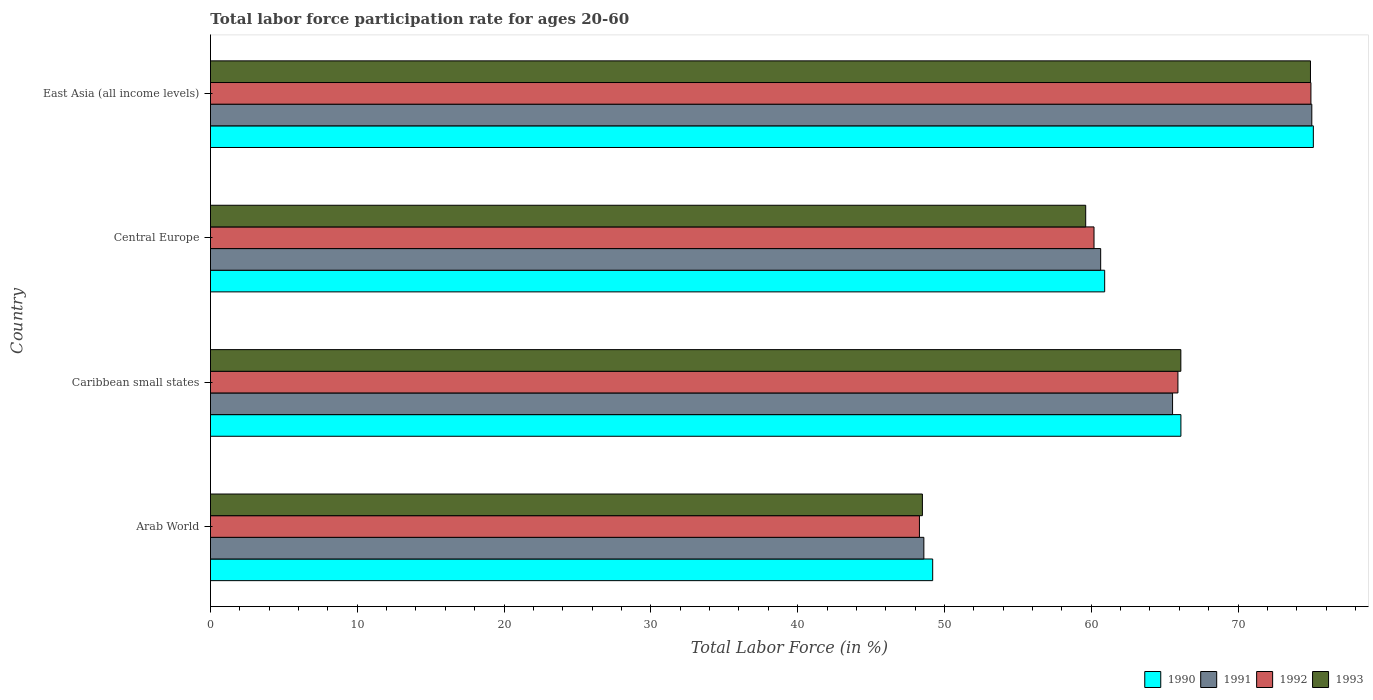How many groups of bars are there?
Give a very brief answer. 4. Are the number of bars per tick equal to the number of legend labels?
Make the answer very short. Yes. Are the number of bars on each tick of the Y-axis equal?
Offer a terse response. Yes. How many bars are there on the 3rd tick from the bottom?
Offer a very short reply. 4. What is the label of the 3rd group of bars from the top?
Your answer should be very brief. Caribbean small states. What is the labor force participation rate in 1991 in East Asia (all income levels)?
Provide a succinct answer. 75.03. Across all countries, what is the maximum labor force participation rate in 1993?
Keep it short and to the point. 74.93. Across all countries, what is the minimum labor force participation rate in 1992?
Offer a terse response. 48.3. In which country was the labor force participation rate in 1992 maximum?
Offer a terse response. East Asia (all income levels). In which country was the labor force participation rate in 1992 minimum?
Your answer should be very brief. Arab World. What is the total labor force participation rate in 1990 in the graph?
Make the answer very short. 251.35. What is the difference between the labor force participation rate in 1991 in Caribbean small states and that in Central Europe?
Give a very brief answer. 4.9. What is the difference between the labor force participation rate in 1991 in Central Europe and the labor force participation rate in 1992 in East Asia (all income levels)?
Ensure brevity in your answer.  -14.32. What is the average labor force participation rate in 1992 per country?
Keep it short and to the point. 62.34. What is the difference between the labor force participation rate in 1990 and labor force participation rate in 1993 in Arab World?
Offer a terse response. 0.7. In how many countries, is the labor force participation rate in 1991 greater than 28 %?
Provide a short and direct response. 4. What is the ratio of the labor force participation rate in 1993 in Caribbean small states to that in Central Europe?
Offer a terse response. 1.11. Is the labor force participation rate in 1992 in Arab World less than that in Caribbean small states?
Provide a succinct answer. Yes. What is the difference between the highest and the second highest labor force participation rate in 1993?
Provide a succinct answer. 8.83. What is the difference between the highest and the lowest labor force participation rate in 1993?
Keep it short and to the point. 26.44. In how many countries, is the labor force participation rate in 1993 greater than the average labor force participation rate in 1993 taken over all countries?
Your answer should be compact. 2. Is the sum of the labor force participation rate in 1990 in Central Europe and East Asia (all income levels) greater than the maximum labor force participation rate in 1993 across all countries?
Offer a very short reply. Yes. Is it the case that in every country, the sum of the labor force participation rate in 1992 and labor force participation rate in 1993 is greater than the sum of labor force participation rate in 1990 and labor force participation rate in 1991?
Your answer should be compact. No. What does the 3rd bar from the bottom in Central Europe represents?
Your answer should be very brief. 1992. Is it the case that in every country, the sum of the labor force participation rate in 1991 and labor force participation rate in 1993 is greater than the labor force participation rate in 1990?
Your answer should be very brief. Yes. How many bars are there?
Provide a short and direct response. 16. Are the values on the major ticks of X-axis written in scientific E-notation?
Offer a very short reply. No. Does the graph contain any zero values?
Give a very brief answer. No. Where does the legend appear in the graph?
Your answer should be very brief. Bottom right. How are the legend labels stacked?
Give a very brief answer. Horizontal. What is the title of the graph?
Make the answer very short. Total labor force participation rate for ages 20-60. What is the label or title of the Y-axis?
Ensure brevity in your answer.  Country. What is the Total Labor Force (in %) of 1990 in Arab World?
Provide a short and direct response. 49.2. What is the Total Labor Force (in %) of 1991 in Arab World?
Give a very brief answer. 48.6. What is the Total Labor Force (in %) in 1992 in Arab World?
Your answer should be very brief. 48.3. What is the Total Labor Force (in %) in 1993 in Arab World?
Your answer should be compact. 48.5. What is the Total Labor Force (in %) in 1990 in Caribbean small states?
Keep it short and to the point. 66.11. What is the Total Labor Force (in %) of 1991 in Caribbean small states?
Your answer should be compact. 65.54. What is the Total Labor Force (in %) in 1992 in Caribbean small states?
Make the answer very short. 65.91. What is the Total Labor Force (in %) in 1993 in Caribbean small states?
Offer a terse response. 66.1. What is the Total Labor Force (in %) of 1990 in Central Europe?
Keep it short and to the point. 60.91. What is the Total Labor Force (in %) in 1991 in Central Europe?
Your answer should be very brief. 60.64. What is the Total Labor Force (in %) in 1992 in Central Europe?
Offer a terse response. 60.19. What is the Total Labor Force (in %) of 1993 in Central Europe?
Provide a short and direct response. 59.62. What is the Total Labor Force (in %) of 1990 in East Asia (all income levels)?
Make the answer very short. 75.13. What is the Total Labor Force (in %) of 1991 in East Asia (all income levels)?
Provide a short and direct response. 75.03. What is the Total Labor Force (in %) in 1992 in East Asia (all income levels)?
Give a very brief answer. 74.97. What is the Total Labor Force (in %) in 1993 in East Asia (all income levels)?
Offer a terse response. 74.93. Across all countries, what is the maximum Total Labor Force (in %) in 1990?
Give a very brief answer. 75.13. Across all countries, what is the maximum Total Labor Force (in %) of 1991?
Offer a terse response. 75.03. Across all countries, what is the maximum Total Labor Force (in %) of 1992?
Your answer should be very brief. 74.97. Across all countries, what is the maximum Total Labor Force (in %) in 1993?
Offer a terse response. 74.93. Across all countries, what is the minimum Total Labor Force (in %) of 1990?
Provide a short and direct response. 49.2. Across all countries, what is the minimum Total Labor Force (in %) in 1991?
Keep it short and to the point. 48.6. Across all countries, what is the minimum Total Labor Force (in %) in 1992?
Offer a terse response. 48.3. Across all countries, what is the minimum Total Labor Force (in %) of 1993?
Offer a very short reply. 48.5. What is the total Total Labor Force (in %) in 1990 in the graph?
Ensure brevity in your answer.  251.35. What is the total Total Labor Force (in %) of 1991 in the graph?
Your response must be concise. 249.81. What is the total Total Labor Force (in %) in 1992 in the graph?
Keep it short and to the point. 249.36. What is the total Total Labor Force (in %) in 1993 in the graph?
Your answer should be compact. 249.16. What is the difference between the Total Labor Force (in %) in 1990 in Arab World and that in Caribbean small states?
Offer a very short reply. -16.91. What is the difference between the Total Labor Force (in %) in 1991 in Arab World and that in Caribbean small states?
Provide a succinct answer. -16.94. What is the difference between the Total Labor Force (in %) of 1992 in Arab World and that in Caribbean small states?
Your response must be concise. -17.61. What is the difference between the Total Labor Force (in %) in 1993 in Arab World and that in Caribbean small states?
Ensure brevity in your answer.  -17.61. What is the difference between the Total Labor Force (in %) of 1990 in Arab World and that in Central Europe?
Provide a short and direct response. -11.72. What is the difference between the Total Labor Force (in %) of 1991 in Arab World and that in Central Europe?
Your answer should be compact. -12.05. What is the difference between the Total Labor Force (in %) in 1992 in Arab World and that in Central Europe?
Keep it short and to the point. -11.89. What is the difference between the Total Labor Force (in %) in 1993 in Arab World and that in Central Europe?
Provide a short and direct response. -11.12. What is the difference between the Total Labor Force (in %) in 1990 in Arab World and that in East Asia (all income levels)?
Keep it short and to the point. -25.93. What is the difference between the Total Labor Force (in %) in 1991 in Arab World and that in East Asia (all income levels)?
Provide a succinct answer. -26.43. What is the difference between the Total Labor Force (in %) in 1992 in Arab World and that in East Asia (all income levels)?
Your answer should be very brief. -26.67. What is the difference between the Total Labor Force (in %) in 1993 in Arab World and that in East Asia (all income levels)?
Your answer should be compact. -26.44. What is the difference between the Total Labor Force (in %) in 1990 in Caribbean small states and that in Central Europe?
Keep it short and to the point. 5.19. What is the difference between the Total Labor Force (in %) of 1991 in Caribbean small states and that in Central Europe?
Your answer should be very brief. 4.9. What is the difference between the Total Labor Force (in %) in 1992 in Caribbean small states and that in Central Europe?
Your response must be concise. 5.72. What is the difference between the Total Labor Force (in %) in 1993 in Caribbean small states and that in Central Europe?
Your answer should be very brief. 6.48. What is the difference between the Total Labor Force (in %) in 1990 in Caribbean small states and that in East Asia (all income levels)?
Provide a succinct answer. -9.02. What is the difference between the Total Labor Force (in %) of 1991 in Caribbean small states and that in East Asia (all income levels)?
Your response must be concise. -9.49. What is the difference between the Total Labor Force (in %) of 1992 in Caribbean small states and that in East Asia (all income levels)?
Your response must be concise. -9.06. What is the difference between the Total Labor Force (in %) in 1993 in Caribbean small states and that in East Asia (all income levels)?
Provide a succinct answer. -8.83. What is the difference between the Total Labor Force (in %) of 1990 in Central Europe and that in East Asia (all income levels)?
Provide a short and direct response. -14.22. What is the difference between the Total Labor Force (in %) of 1991 in Central Europe and that in East Asia (all income levels)?
Provide a succinct answer. -14.38. What is the difference between the Total Labor Force (in %) in 1992 in Central Europe and that in East Asia (all income levels)?
Your response must be concise. -14.78. What is the difference between the Total Labor Force (in %) of 1993 in Central Europe and that in East Asia (all income levels)?
Give a very brief answer. -15.31. What is the difference between the Total Labor Force (in %) in 1990 in Arab World and the Total Labor Force (in %) in 1991 in Caribbean small states?
Offer a very short reply. -16.34. What is the difference between the Total Labor Force (in %) in 1990 in Arab World and the Total Labor Force (in %) in 1992 in Caribbean small states?
Give a very brief answer. -16.71. What is the difference between the Total Labor Force (in %) in 1990 in Arab World and the Total Labor Force (in %) in 1993 in Caribbean small states?
Your response must be concise. -16.91. What is the difference between the Total Labor Force (in %) of 1991 in Arab World and the Total Labor Force (in %) of 1992 in Caribbean small states?
Keep it short and to the point. -17.31. What is the difference between the Total Labor Force (in %) of 1991 in Arab World and the Total Labor Force (in %) of 1993 in Caribbean small states?
Ensure brevity in your answer.  -17.51. What is the difference between the Total Labor Force (in %) of 1992 in Arab World and the Total Labor Force (in %) of 1993 in Caribbean small states?
Your answer should be very brief. -17.81. What is the difference between the Total Labor Force (in %) in 1990 in Arab World and the Total Labor Force (in %) in 1991 in Central Europe?
Your answer should be compact. -11.44. What is the difference between the Total Labor Force (in %) of 1990 in Arab World and the Total Labor Force (in %) of 1992 in Central Europe?
Provide a short and direct response. -10.99. What is the difference between the Total Labor Force (in %) in 1990 in Arab World and the Total Labor Force (in %) in 1993 in Central Europe?
Ensure brevity in your answer.  -10.42. What is the difference between the Total Labor Force (in %) of 1991 in Arab World and the Total Labor Force (in %) of 1992 in Central Europe?
Your response must be concise. -11.59. What is the difference between the Total Labor Force (in %) of 1991 in Arab World and the Total Labor Force (in %) of 1993 in Central Europe?
Your answer should be very brief. -11.03. What is the difference between the Total Labor Force (in %) in 1992 in Arab World and the Total Labor Force (in %) in 1993 in Central Europe?
Provide a short and direct response. -11.33. What is the difference between the Total Labor Force (in %) in 1990 in Arab World and the Total Labor Force (in %) in 1991 in East Asia (all income levels)?
Ensure brevity in your answer.  -25.83. What is the difference between the Total Labor Force (in %) of 1990 in Arab World and the Total Labor Force (in %) of 1992 in East Asia (all income levels)?
Keep it short and to the point. -25.77. What is the difference between the Total Labor Force (in %) of 1990 in Arab World and the Total Labor Force (in %) of 1993 in East Asia (all income levels)?
Keep it short and to the point. -25.74. What is the difference between the Total Labor Force (in %) of 1991 in Arab World and the Total Labor Force (in %) of 1992 in East Asia (all income levels)?
Provide a short and direct response. -26.37. What is the difference between the Total Labor Force (in %) of 1991 in Arab World and the Total Labor Force (in %) of 1993 in East Asia (all income levels)?
Offer a terse response. -26.34. What is the difference between the Total Labor Force (in %) in 1992 in Arab World and the Total Labor Force (in %) in 1993 in East Asia (all income levels)?
Your answer should be compact. -26.64. What is the difference between the Total Labor Force (in %) in 1990 in Caribbean small states and the Total Labor Force (in %) in 1991 in Central Europe?
Provide a succinct answer. 5.47. What is the difference between the Total Labor Force (in %) in 1990 in Caribbean small states and the Total Labor Force (in %) in 1992 in Central Europe?
Provide a short and direct response. 5.92. What is the difference between the Total Labor Force (in %) of 1990 in Caribbean small states and the Total Labor Force (in %) of 1993 in Central Europe?
Give a very brief answer. 6.49. What is the difference between the Total Labor Force (in %) of 1991 in Caribbean small states and the Total Labor Force (in %) of 1992 in Central Europe?
Offer a terse response. 5.35. What is the difference between the Total Labor Force (in %) of 1991 in Caribbean small states and the Total Labor Force (in %) of 1993 in Central Europe?
Offer a very short reply. 5.92. What is the difference between the Total Labor Force (in %) in 1992 in Caribbean small states and the Total Labor Force (in %) in 1993 in Central Europe?
Ensure brevity in your answer.  6.28. What is the difference between the Total Labor Force (in %) of 1990 in Caribbean small states and the Total Labor Force (in %) of 1991 in East Asia (all income levels)?
Offer a terse response. -8.92. What is the difference between the Total Labor Force (in %) of 1990 in Caribbean small states and the Total Labor Force (in %) of 1992 in East Asia (all income levels)?
Offer a terse response. -8.86. What is the difference between the Total Labor Force (in %) in 1990 in Caribbean small states and the Total Labor Force (in %) in 1993 in East Asia (all income levels)?
Make the answer very short. -8.83. What is the difference between the Total Labor Force (in %) of 1991 in Caribbean small states and the Total Labor Force (in %) of 1992 in East Asia (all income levels)?
Provide a short and direct response. -9.43. What is the difference between the Total Labor Force (in %) of 1991 in Caribbean small states and the Total Labor Force (in %) of 1993 in East Asia (all income levels)?
Give a very brief answer. -9.4. What is the difference between the Total Labor Force (in %) of 1992 in Caribbean small states and the Total Labor Force (in %) of 1993 in East Asia (all income levels)?
Keep it short and to the point. -9.03. What is the difference between the Total Labor Force (in %) in 1990 in Central Europe and the Total Labor Force (in %) in 1991 in East Asia (all income levels)?
Ensure brevity in your answer.  -14.11. What is the difference between the Total Labor Force (in %) in 1990 in Central Europe and the Total Labor Force (in %) in 1992 in East Asia (all income levels)?
Give a very brief answer. -14.05. What is the difference between the Total Labor Force (in %) in 1990 in Central Europe and the Total Labor Force (in %) in 1993 in East Asia (all income levels)?
Provide a short and direct response. -14.02. What is the difference between the Total Labor Force (in %) in 1991 in Central Europe and the Total Labor Force (in %) in 1992 in East Asia (all income levels)?
Your answer should be compact. -14.32. What is the difference between the Total Labor Force (in %) of 1991 in Central Europe and the Total Labor Force (in %) of 1993 in East Asia (all income levels)?
Your answer should be very brief. -14.29. What is the difference between the Total Labor Force (in %) in 1992 in Central Europe and the Total Labor Force (in %) in 1993 in East Asia (all income levels)?
Keep it short and to the point. -14.75. What is the average Total Labor Force (in %) in 1990 per country?
Your answer should be compact. 62.84. What is the average Total Labor Force (in %) of 1991 per country?
Offer a terse response. 62.45. What is the average Total Labor Force (in %) in 1992 per country?
Provide a short and direct response. 62.34. What is the average Total Labor Force (in %) in 1993 per country?
Provide a short and direct response. 62.29. What is the difference between the Total Labor Force (in %) of 1990 and Total Labor Force (in %) of 1991 in Arab World?
Provide a succinct answer. 0.6. What is the difference between the Total Labor Force (in %) in 1990 and Total Labor Force (in %) in 1992 in Arab World?
Your answer should be very brief. 0.9. What is the difference between the Total Labor Force (in %) in 1990 and Total Labor Force (in %) in 1993 in Arab World?
Give a very brief answer. 0.7. What is the difference between the Total Labor Force (in %) of 1991 and Total Labor Force (in %) of 1992 in Arab World?
Provide a short and direct response. 0.3. What is the difference between the Total Labor Force (in %) of 1991 and Total Labor Force (in %) of 1993 in Arab World?
Your answer should be very brief. 0.1. What is the difference between the Total Labor Force (in %) in 1992 and Total Labor Force (in %) in 1993 in Arab World?
Ensure brevity in your answer.  -0.2. What is the difference between the Total Labor Force (in %) of 1990 and Total Labor Force (in %) of 1991 in Caribbean small states?
Keep it short and to the point. 0.57. What is the difference between the Total Labor Force (in %) of 1990 and Total Labor Force (in %) of 1992 in Caribbean small states?
Ensure brevity in your answer.  0.2. What is the difference between the Total Labor Force (in %) in 1990 and Total Labor Force (in %) in 1993 in Caribbean small states?
Your answer should be compact. 0. What is the difference between the Total Labor Force (in %) in 1991 and Total Labor Force (in %) in 1992 in Caribbean small states?
Provide a short and direct response. -0.37. What is the difference between the Total Labor Force (in %) in 1991 and Total Labor Force (in %) in 1993 in Caribbean small states?
Ensure brevity in your answer.  -0.57. What is the difference between the Total Labor Force (in %) of 1992 and Total Labor Force (in %) of 1993 in Caribbean small states?
Make the answer very short. -0.2. What is the difference between the Total Labor Force (in %) in 1990 and Total Labor Force (in %) in 1991 in Central Europe?
Your answer should be compact. 0.27. What is the difference between the Total Labor Force (in %) of 1990 and Total Labor Force (in %) of 1992 in Central Europe?
Offer a very short reply. 0.73. What is the difference between the Total Labor Force (in %) of 1990 and Total Labor Force (in %) of 1993 in Central Europe?
Your answer should be compact. 1.29. What is the difference between the Total Labor Force (in %) in 1991 and Total Labor Force (in %) in 1992 in Central Europe?
Your answer should be very brief. 0.45. What is the difference between the Total Labor Force (in %) in 1992 and Total Labor Force (in %) in 1993 in Central Europe?
Offer a terse response. 0.57. What is the difference between the Total Labor Force (in %) of 1990 and Total Labor Force (in %) of 1991 in East Asia (all income levels)?
Offer a terse response. 0.1. What is the difference between the Total Labor Force (in %) in 1990 and Total Labor Force (in %) in 1992 in East Asia (all income levels)?
Offer a terse response. 0.17. What is the difference between the Total Labor Force (in %) of 1990 and Total Labor Force (in %) of 1993 in East Asia (all income levels)?
Offer a terse response. 0.2. What is the difference between the Total Labor Force (in %) in 1991 and Total Labor Force (in %) in 1992 in East Asia (all income levels)?
Keep it short and to the point. 0.06. What is the difference between the Total Labor Force (in %) of 1991 and Total Labor Force (in %) of 1993 in East Asia (all income levels)?
Provide a succinct answer. 0.09. What is the difference between the Total Labor Force (in %) of 1992 and Total Labor Force (in %) of 1993 in East Asia (all income levels)?
Offer a terse response. 0.03. What is the ratio of the Total Labor Force (in %) in 1990 in Arab World to that in Caribbean small states?
Provide a succinct answer. 0.74. What is the ratio of the Total Labor Force (in %) of 1991 in Arab World to that in Caribbean small states?
Your answer should be very brief. 0.74. What is the ratio of the Total Labor Force (in %) in 1992 in Arab World to that in Caribbean small states?
Provide a short and direct response. 0.73. What is the ratio of the Total Labor Force (in %) in 1993 in Arab World to that in Caribbean small states?
Make the answer very short. 0.73. What is the ratio of the Total Labor Force (in %) of 1990 in Arab World to that in Central Europe?
Ensure brevity in your answer.  0.81. What is the ratio of the Total Labor Force (in %) of 1991 in Arab World to that in Central Europe?
Offer a very short reply. 0.8. What is the ratio of the Total Labor Force (in %) of 1992 in Arab World to that in Central Europe?
Give a very brief answer. 0.8. What is the ratio of the Total Labor Force (in %) of 1993 in Arab World to that in Central Europe?
Offer a terse response. 0.81. What is the ratio of the Total Labor Force (in %) of 1990 in Arab World to that in East Asia (all income levels)?
Make the answer very short. 0.65. What is the ratio of the Total Labor Force (in %) in 1991 in Arab World to that in East Asia (all income levels)?
Ensure brevity in your answer.  0.65. What is the ratio of the Total Labor Force (in %) in 1992 in Arab World to that in East Asia (all income levels)?
Make the answer very short. 0.64. What is the ratio of the Total Labor Force (in %) of 1993 in Arab World to that in East Asia (all income levels)?
Offer a very short reply. 0.65. What is the ratio of the Total Labor Force (in %) of 1990 in Caribbean small states to that in Central Europe?
Make the answer very short. 1.09. What is the ratio of the Total Labor Force (in %) in 1991 in Caribbean small states to that in Central Europe?
Your answer should be very brief. 1.08. What is the ratio of the Total Labor Force (in %) in 1992 in Caribbean small states to that in Central Europe?
Offer a terse response. 1.09. What is the ratio of the Total Labor Force (in %) of 1993 in Caribbean small states to that in Central Europe?
Give a very brief answer. 1.11. What is the ratio of the Total Labor Force (in %) in 1990 in Caribbean small states to that in East Asia (all income levels)?
Provide a short and direct response. 0.88. What is the ratio of the Total Labor Force (in %) of 1991 in Caribbean small states to that in East Asia (all income levels)?
Your answer should be compact. 0.87. What is the ratio of the Total Labor Force (in %) in 1992 in Caribbean small states to that in East Asia (all income levels)?
Ensure brevity in your answer.  0.88. What is the ratio of the Total Labor Force (in %) of 1993 in Caribbean small states to that in East Asia (all income levels)?
Ensure brevity in your answer.  0.88. What is the ratio of the Total Labor Force (in %) in 1990 in Central Europe to that in East Asia (all income levels)?
Ensure brevity in your answer.  0.81. What is the ratio of the Total Labor Force (in %) in 1991 in Central Europe to that in East Asia (all income levels)?
Provide a short and direct response. 0.81. What is the ratio of the Total Labor Force (in %) of 1992 in Central Europe to that in East Asia (all income levels)?
Provide a short and direct response. 0.8. What is the ratio of the Total Labor Force (in %) in 1993 in Central Europe to that in East Asia (all income levels)?
Keep it short and to the point. 0.8. What is the difference between the highest and the second highest Total Labor Force (in %) of 1990?
Your response must be concise. 9.02. What is the difference between the highest and the second highest Total Labor Force (in %) of 1991?
Make the answer very short. 9.49. What is the difference between the highest and the second highest Total Labor Force (in %) in 1992?
Your answer should be compact. 9.06. What is the difference between the highest and the second highest Total Labor Force (in %) in 1993?
Ensure brevity in your answer.  8.83. What is the difference between the highest and the lowest Total Labor Force (in %) of 1990?
Provide a short and direct response. 25.93. What is the difference between the highest and the lowest Total Labor Force (in %) of 1991?
Give a very brief answer. 26.43. What is the difference between the highest and the lowest Total Labor Force (in %) of 1992?
Give a very brief answer. 26.67. What is the difference between the highest and the lowest Total Labor Force (in %) of 1993?
Provide a short and direct response. 26.44. 